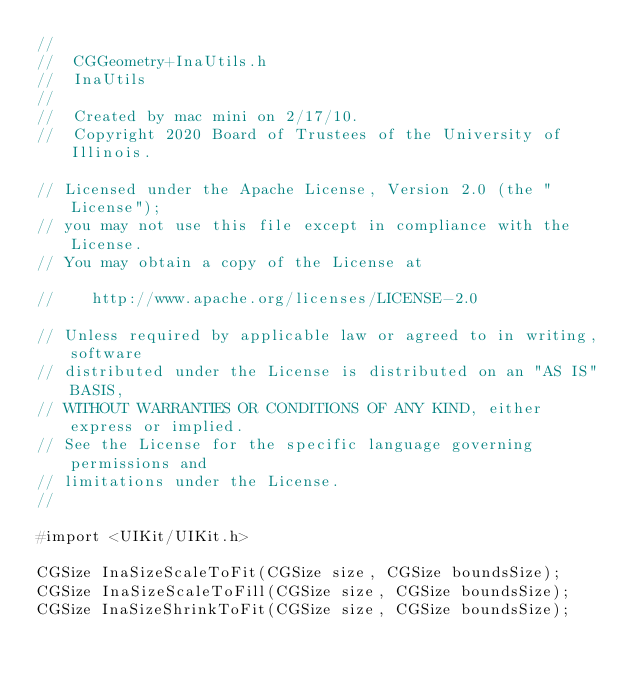Convert code to text. <code><loc_0><loc_0><loc_500><loc_500><_C_>//
//  CGGeometry+InaUtils.h
//  InaUtils
//
//  Created by mac mini on 2/17/10.
//  Copyright 2020 Board of Trustees of the University of Illinois.
    
// Licensed under the Apache License, Version 2.0 (the "License");
// you may not use this file except in compliance with the License.
// You may obtain a copy of the License at

//    http://www.apache.org/licenses/LICENSE-2.0

// Unless required by applicable law or agreed to in writing, software
// distributed under the License is distributed on an "AS IS" BASIS,
// WITHOUT WARRANTIES OR CONDITIONS OF ANY KIND, either express or implied.
// See the License for the specific language governing permissions and
// limitations under the License.
//

#import <UIKit/UIKit.h>

CGSize InaSizeScaleToFit(CGSize size, CGSize boundsSize);
CGSize InaSizeScaleToFill(CGSize size, CGSize boundsSize);
CGSize InaSizeShrinkToFit(CGSize size, CGSize boundsSize);

</code> 